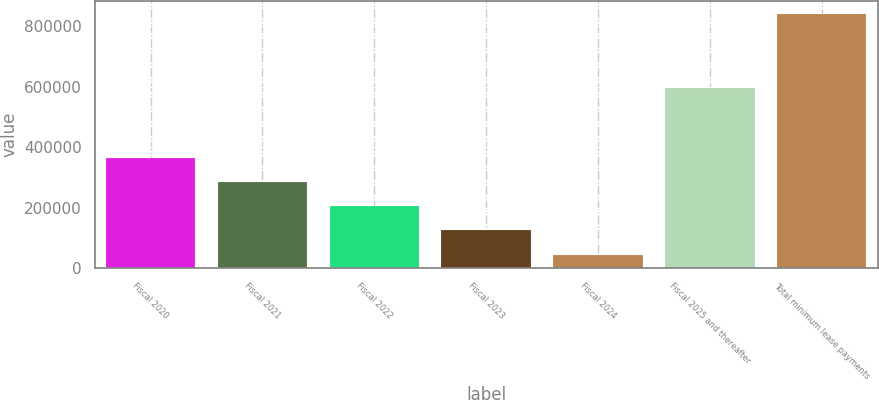<chart> <loc_0><loc_0><loc_500><loc_500><bar_chart><fcel>Fiscal 2020<fcel>Fiscal 2021<fcel>Fiscal 2022<fcel>Fiscal 2023<fcel>Fiscal 2024<fcel>Fiscal 2025 and thereafter<fcel>Total minimum lease payments<nl><fcel>364109<fcel>284348<fcel>204588<fcel>124828<fcel>45067<fcel>595047<fcel>842672<nl></chart> 